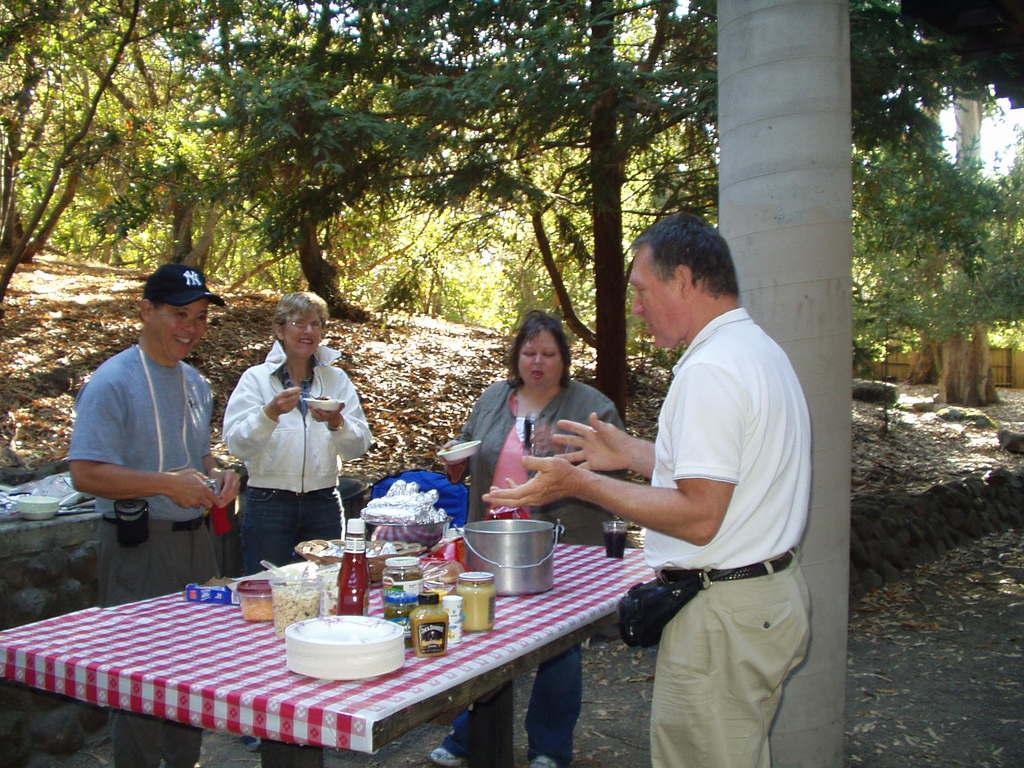How would you summarize this image in a sentence or two? In this image there are four person standing on the table there are plates,bowl,food,glass. At the back side there are tree. 